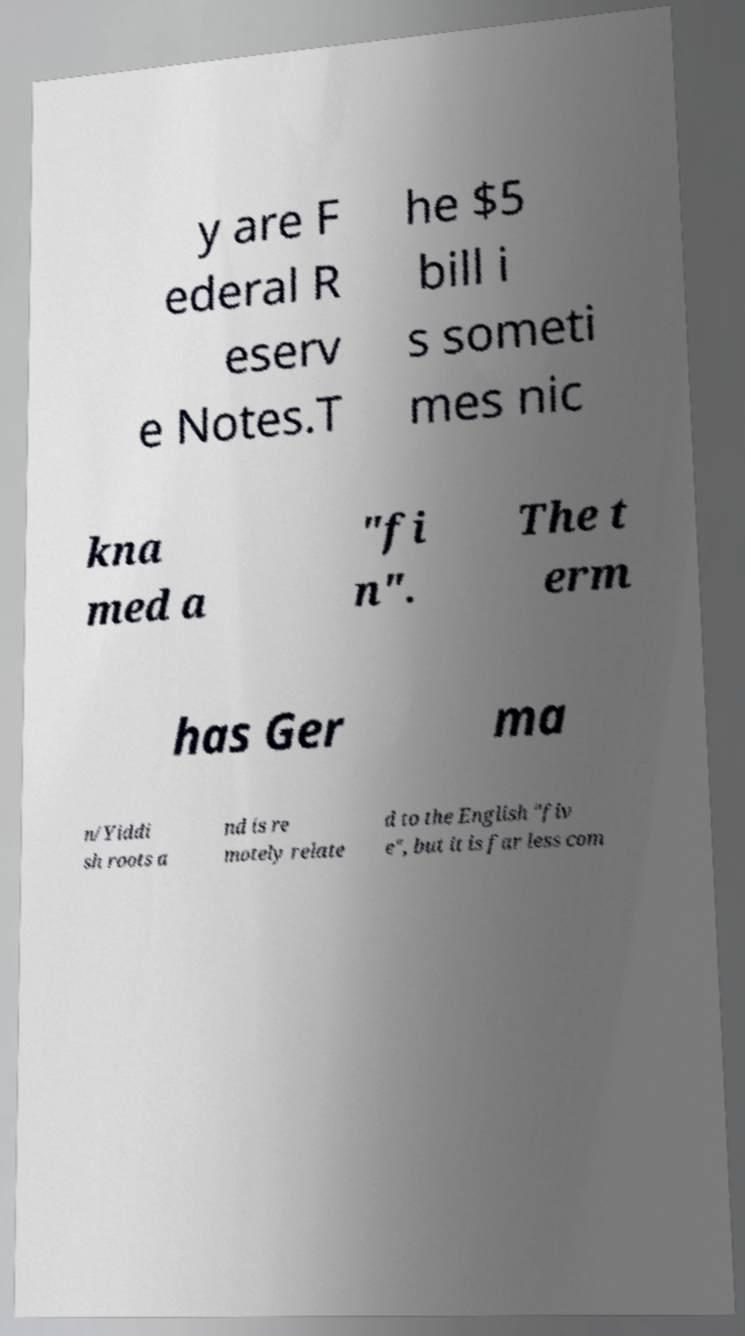Could you assist in decoding the text presented in this image and type it out clearly? y are F ederal R eserv e Notes.T he $5 bill i s someti mes nic kna med a "fi n". The t erm has Ger ma n/Yiddi sh roots a nd is re motely relate d to the English "fiv e", but it is far less com 